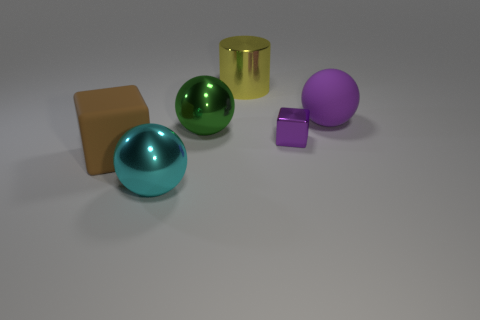There is a rubber object to the left of the thing in front of the rubber object that is left of the tiny cube; how big is it?
Provide a short and direct response. Large. There is a brown rubber object; is it the same shape as the big thing on the right side of the big shiny cylinder?
Offer a very short reply. No. What is the purple cube made of?
Ensure brevity in your answer.  Metal. How many rubber things are brown objects or big green blocks?
Offer a very short reply. 1. Are there fewer large rubber things to the right of the cyan ball than large things that are in front of the big purple rubber object?
Ensure brevity in your answer.  Yes. Are there any large matte spheres in front of the metal thing that is in front of the large matte thing that is on the left side of the big purple object?
Your answer should be very brief. No. What is the material of the tiny block that is the same color as the matte ball?
Provide a short and direct response. Metal. There is a matte object that is right of the small purple metallic object; does it have the same shape as the shiny object that is on the left side of the green metallic thing?
Keep it short and to the point. Yes. There is a green ball that is the same size as the purple ball; what material is it?
Ensure brevity in your answer.  Metal. Is the material of the large sphere right of the large yellow object the same as the ball in front of the tiny purple metal thing?
Make the answer very short. No. 